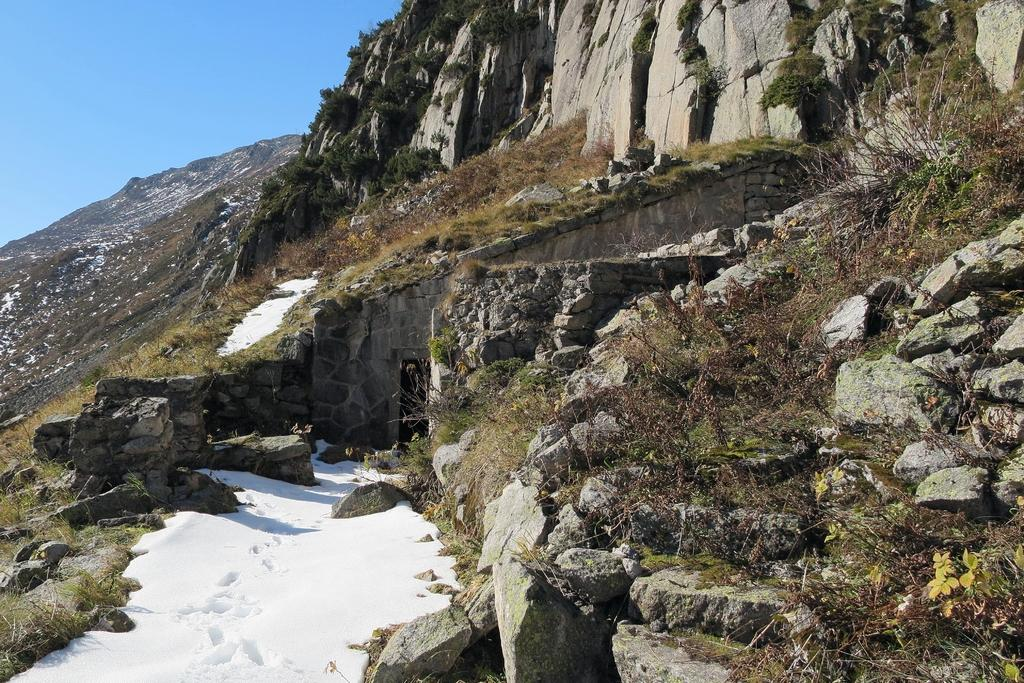What type of natural formation can be seen in the image? There are mountains in the image. What is covering the ground in the image? There is snow and grass in the image. What type of vegetation is present in the image? There are plants in the image. What can be seen in the background of the image? The sky is visible in the background of the image. Where is the prison located in the image? There is no prison present in the image. What type of notebook is being used to take notes about the mountains? There is no notebook present in the image. 